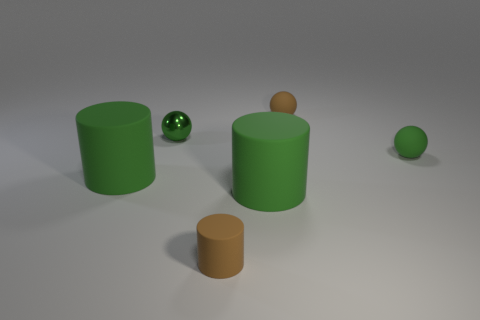Subtract 1 balls. How many balls are left? 2 Add 4 big green rubber objects. How many objects exist? 10 Add 2 brown spheres. How many brown spheres exist? 3 Subtract 0 blue blocks. How many objects are left? 6 Subtract all green rubber objects. Subtract all big shiny balls. How many objects are left? 3 Add 6 brown matte cylinders. How many brown matte cylinders are left? 7 